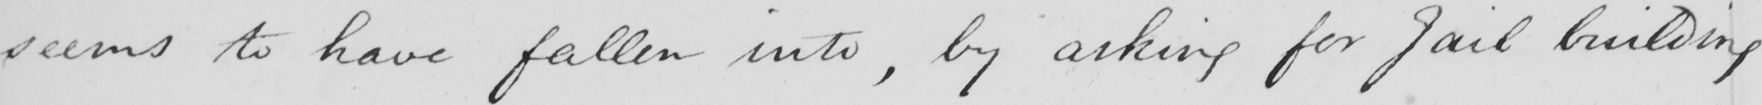Can you tell me what this handwritten text says? seems to have fallen into , by asking for Jail building 